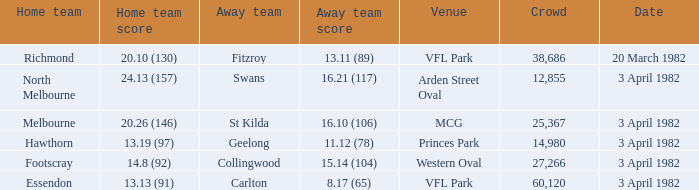Could you help me parse every detail presented in this table? {'header': ['Home team', 'Home team score', 'Away team', 'Away team score', 'Venue', 'Crowd', 'Date'], 'rows': [['Richmond', '20.10 (130)', 'Fitzroy', '13.11 (89)', 'VFL Park', '38,686', '20 March 1982'], ['North Melbourne', '24.13 (157)', 'Swans', '16.21 (117)', 'Arden Street Oval', '12,855', '3 April 1982'], ['Melbourne', '20.26 (146)', 'St Kilda', '16.10 (106)', 'MCG', '25,367', '3 April 1982'], ['Hawthorn', '13.19 (97)', 'Geelong', '11.12 (78)', 'Princes Park', '14,980', '3 April 1982'], ['Footscray', '14.8 (92)', 'Collingwood', '15.14 (104)', 'Western Oval', '27,266', '3 April 1982'], ['Essendon', '13.13 (91)', 'Carlton', '8.17 (65)', 'VFL Park', '60,120', '3 April 1982']]} What total did the north melbourne home team achieve? 24.13 (157). 